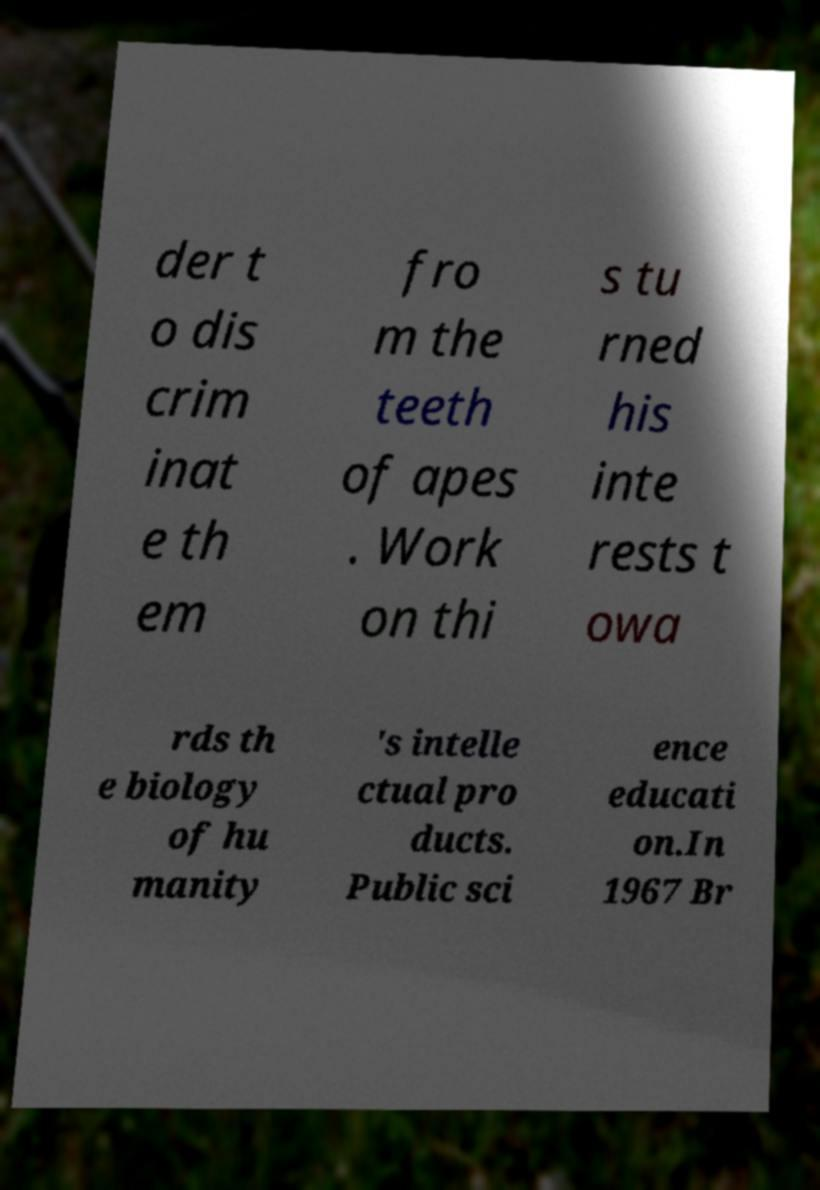There's text embedded in this image that I need extracted. Can you transcribe it verbatim? der t o dis crim inat e th em fro m the teeth of apes . Work on thi s tu rned his inte rests t owa rds th e biology of hu manity 's intelle ctual pro ducts. Public sci ence educati on.In 1967 Br 